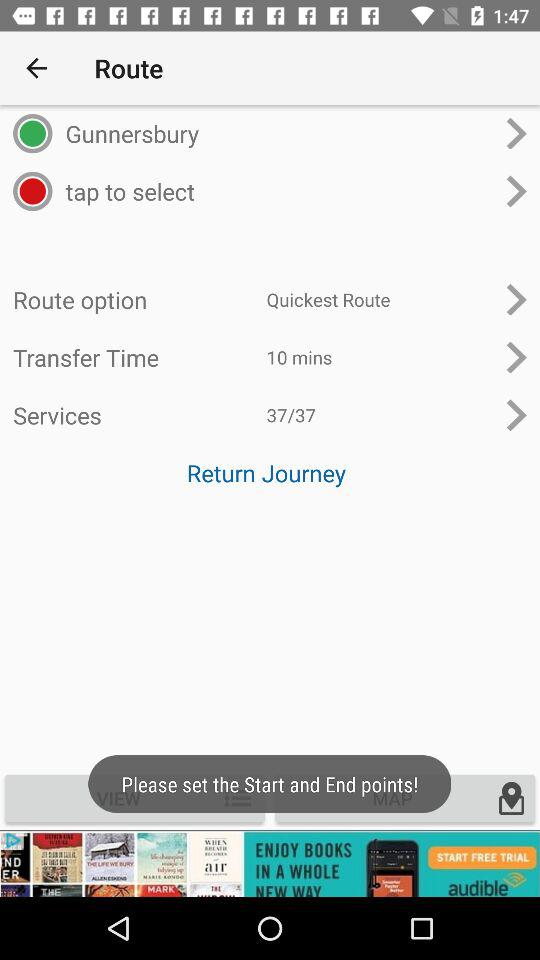What is the current number of services? The current number of services is 37. 